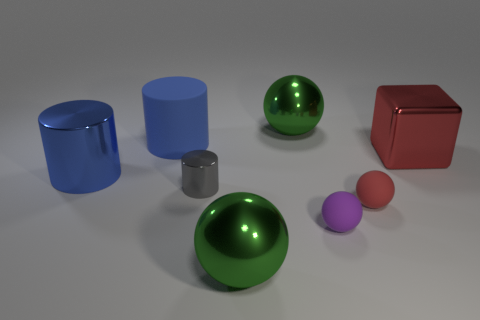Are there any tiny purple objects of the same shape as the blue rubber thing? Yes, there are tiny purple spheres in the image that share the same shape as the larger blue spherical object. 